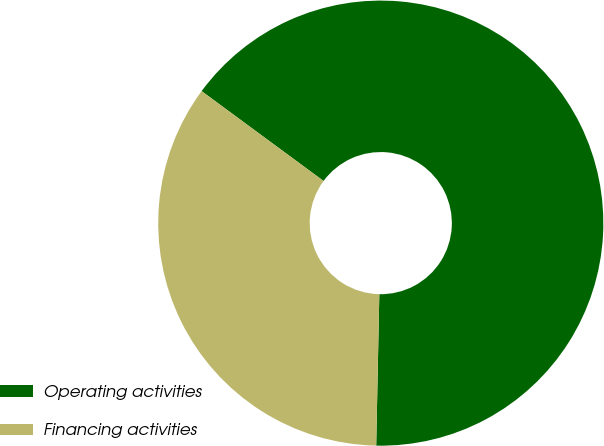Convert chart. <chart><loc_0><loc_0><loc_500><loc_500><pie_chart><fcel>Operating activities<fcel>Financing activities<nl><fcel>65.22%<fcel>34.78%<nl></chart> 